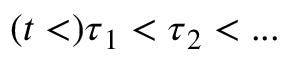<formula> <loc_0><loc_0><loc_500><loc_500>( t < ) \tau _ { 1 } < \tau _ { 2 } < \dots</formula> 